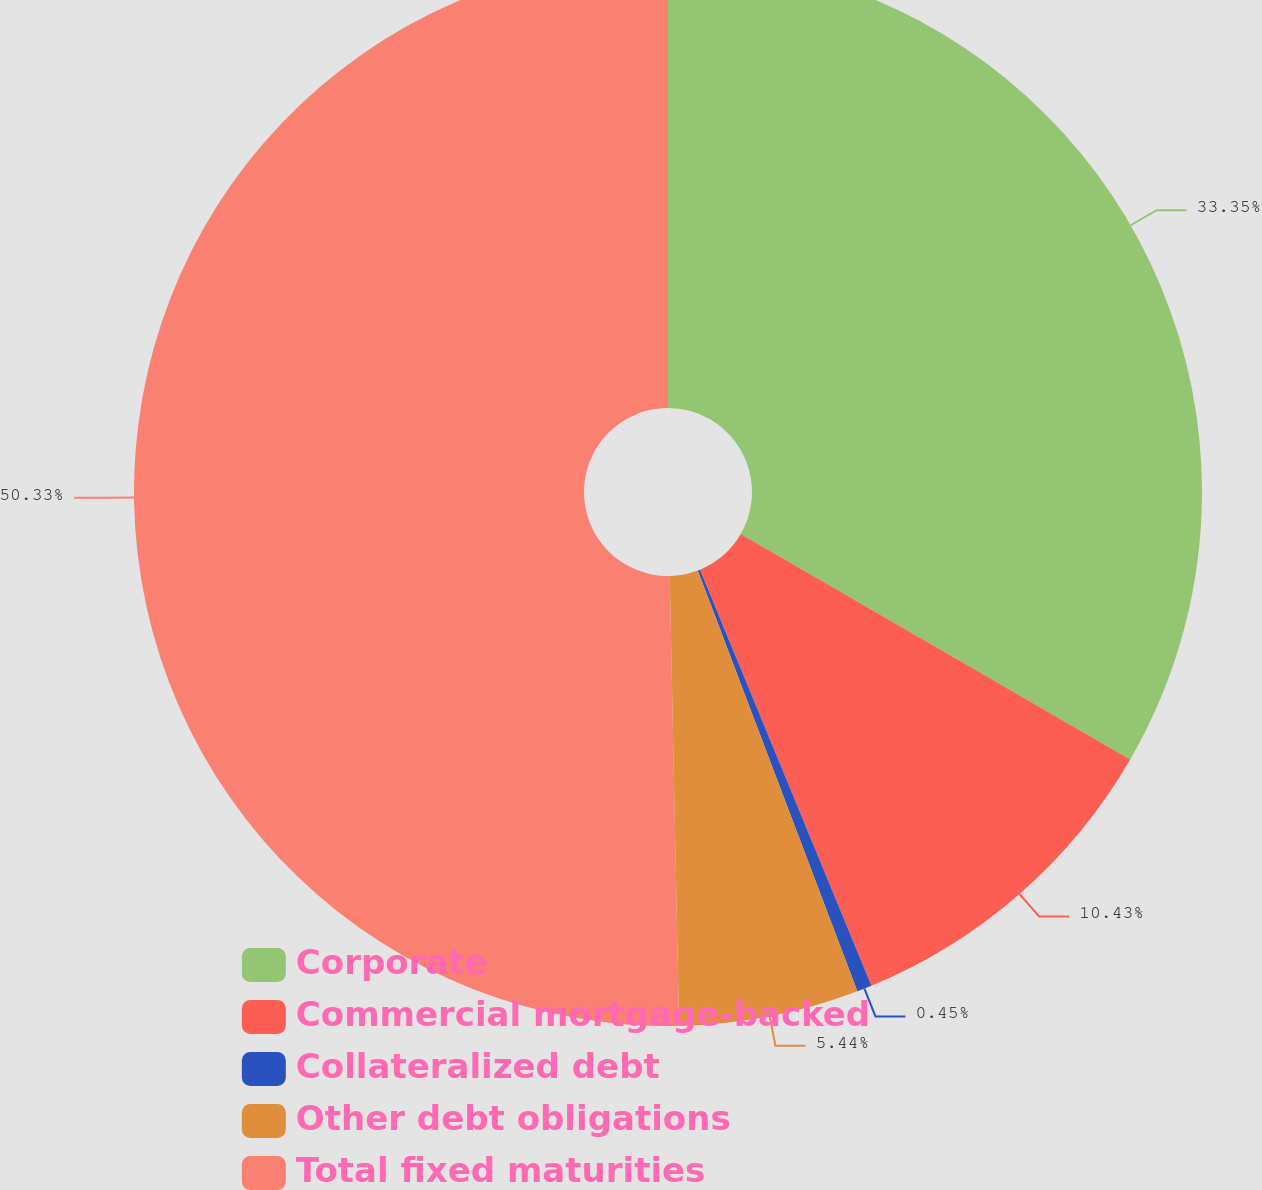<chart> <loc_0><loc_0><loc_500><loc_500><pie_chart><fcel>Corporate<fcel>Commercial mortgage-backed<fcel>Collateralized debt<fcel>Other debt obligations<fcel>Total fixed maturities<nl><fcel>33.35%<fcel>10.43%<fcel>0.45%<fcel>5.44%<fcel>50.33%<nl></chart> 